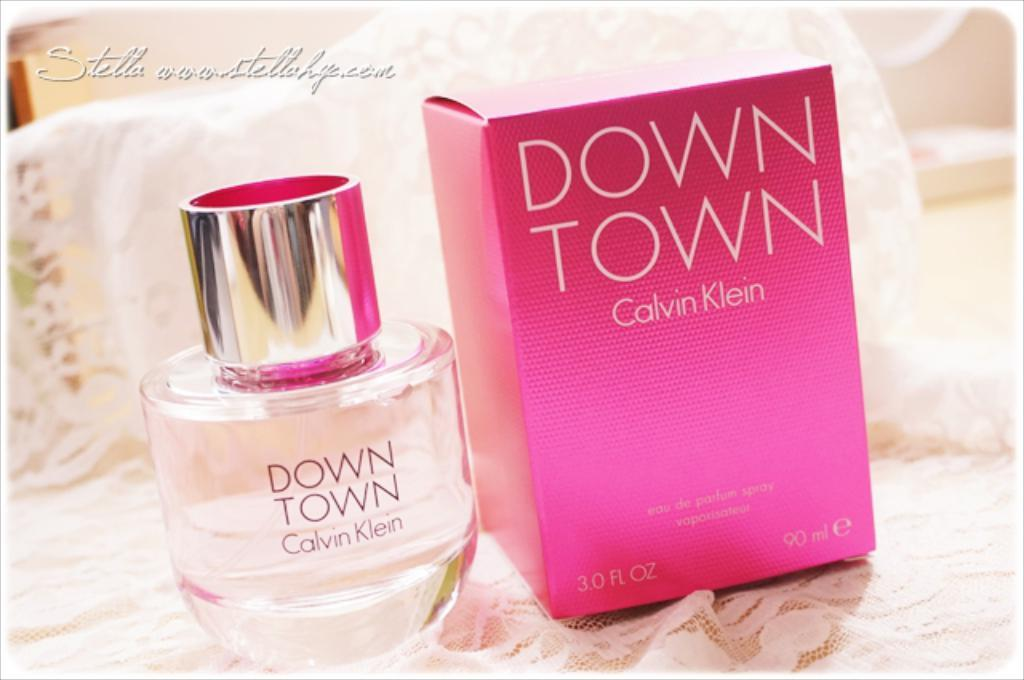<image>
Give a short and clear explanation of the subsequent image. A bottle of Down Town perfume by Calvin Klein. 